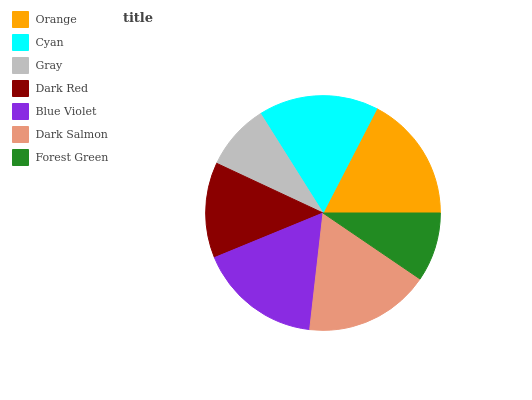Is Gray the minimum?
Answer yes or no. Yes. Is Orange the maximum?
Answer yes or no. Yes. Is Cyan the minimum?
Answer yes or no. No. Is Cyan the maximum?
Answer yes or no. No. Is Orange greater than Cyan?
Answer yes or no. Yes. Is Cyan less than Orange?
Answer yes or no. Yes. Is Cyan greater than Orange?
Answer yes or no. No. Is Orange less than Cyan?
Answer yes or no. No. Is Cyan the high median?
Answer yes or no. Yes. Is Cyan the low median?
Answer yes or no. Yes. Is Forest Green the high median?
Answer yes or no. No. Is Blue Violet the low median?
Answer yes or no. No. 